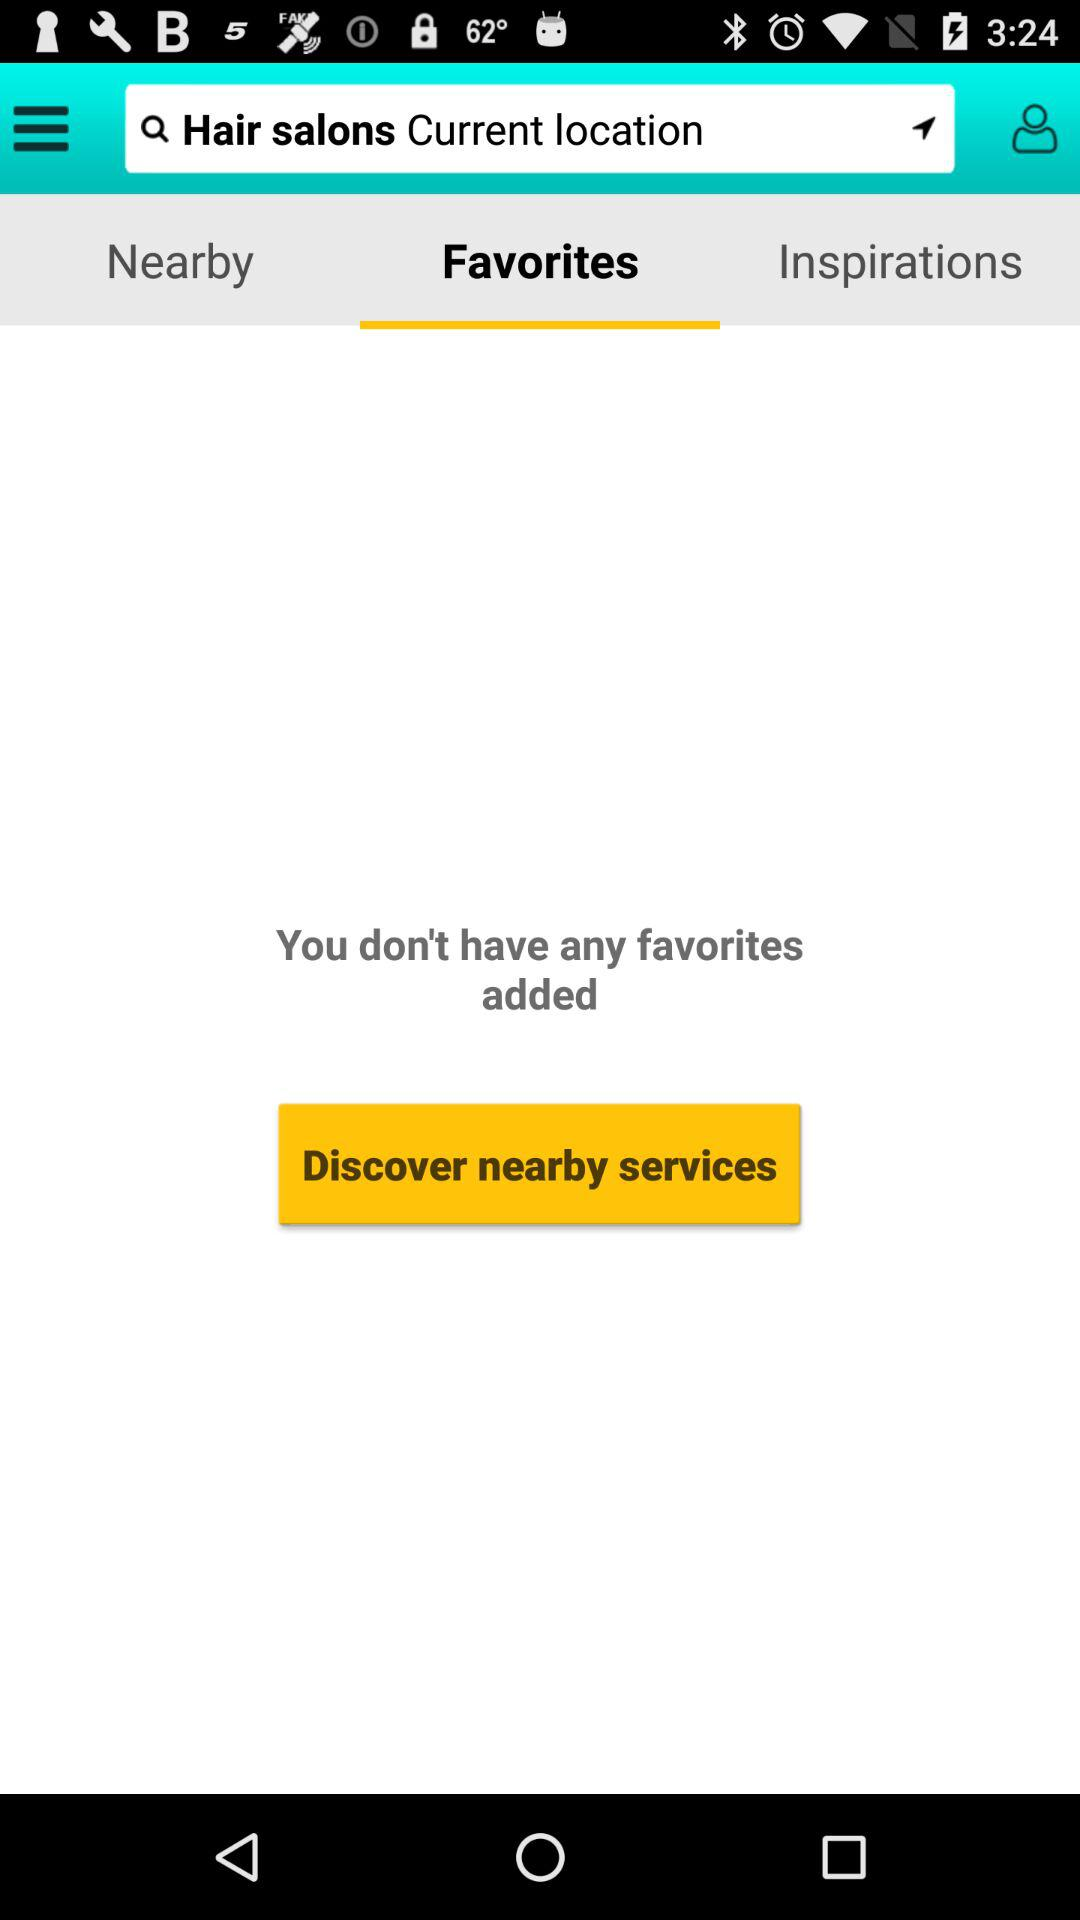Which tab is selected? The selected tab is "Favorites". 